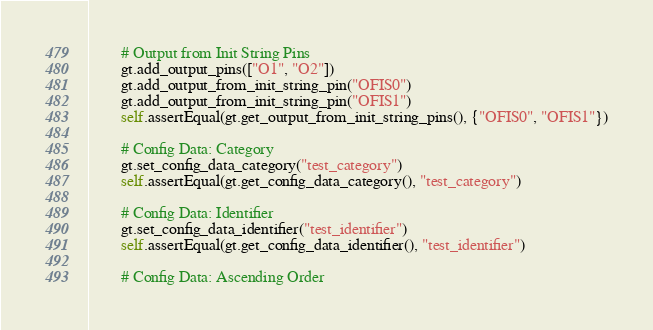Convert code to text. <code><loc_0><loc_0><loc_500><loc_500><_Python_>
        # Output from Init String Pins
        gt.add_output_pins(["O1", "O2"])
        gt.add_output_from_init_string_pin("OFIS0")
        gt.add_output_from_init_string_pin("OFIS1")
        self.assertEqual(gt.get_output_from_init_string_pins(), {"OFIS0", "OFIS1"})

        # Config Data: Category
        gt.set_config_data_category("test_category")
        self.assertEqual(gt.get_config_data_category(), "test_category")

        # Config Data: Identifier
        gt.set_config_data_identifier("test_identifier")
        self.assertEqual(gt.get_config_data_identifier(), "test_identifier")

        # Config Data: Ascending Order</code> 